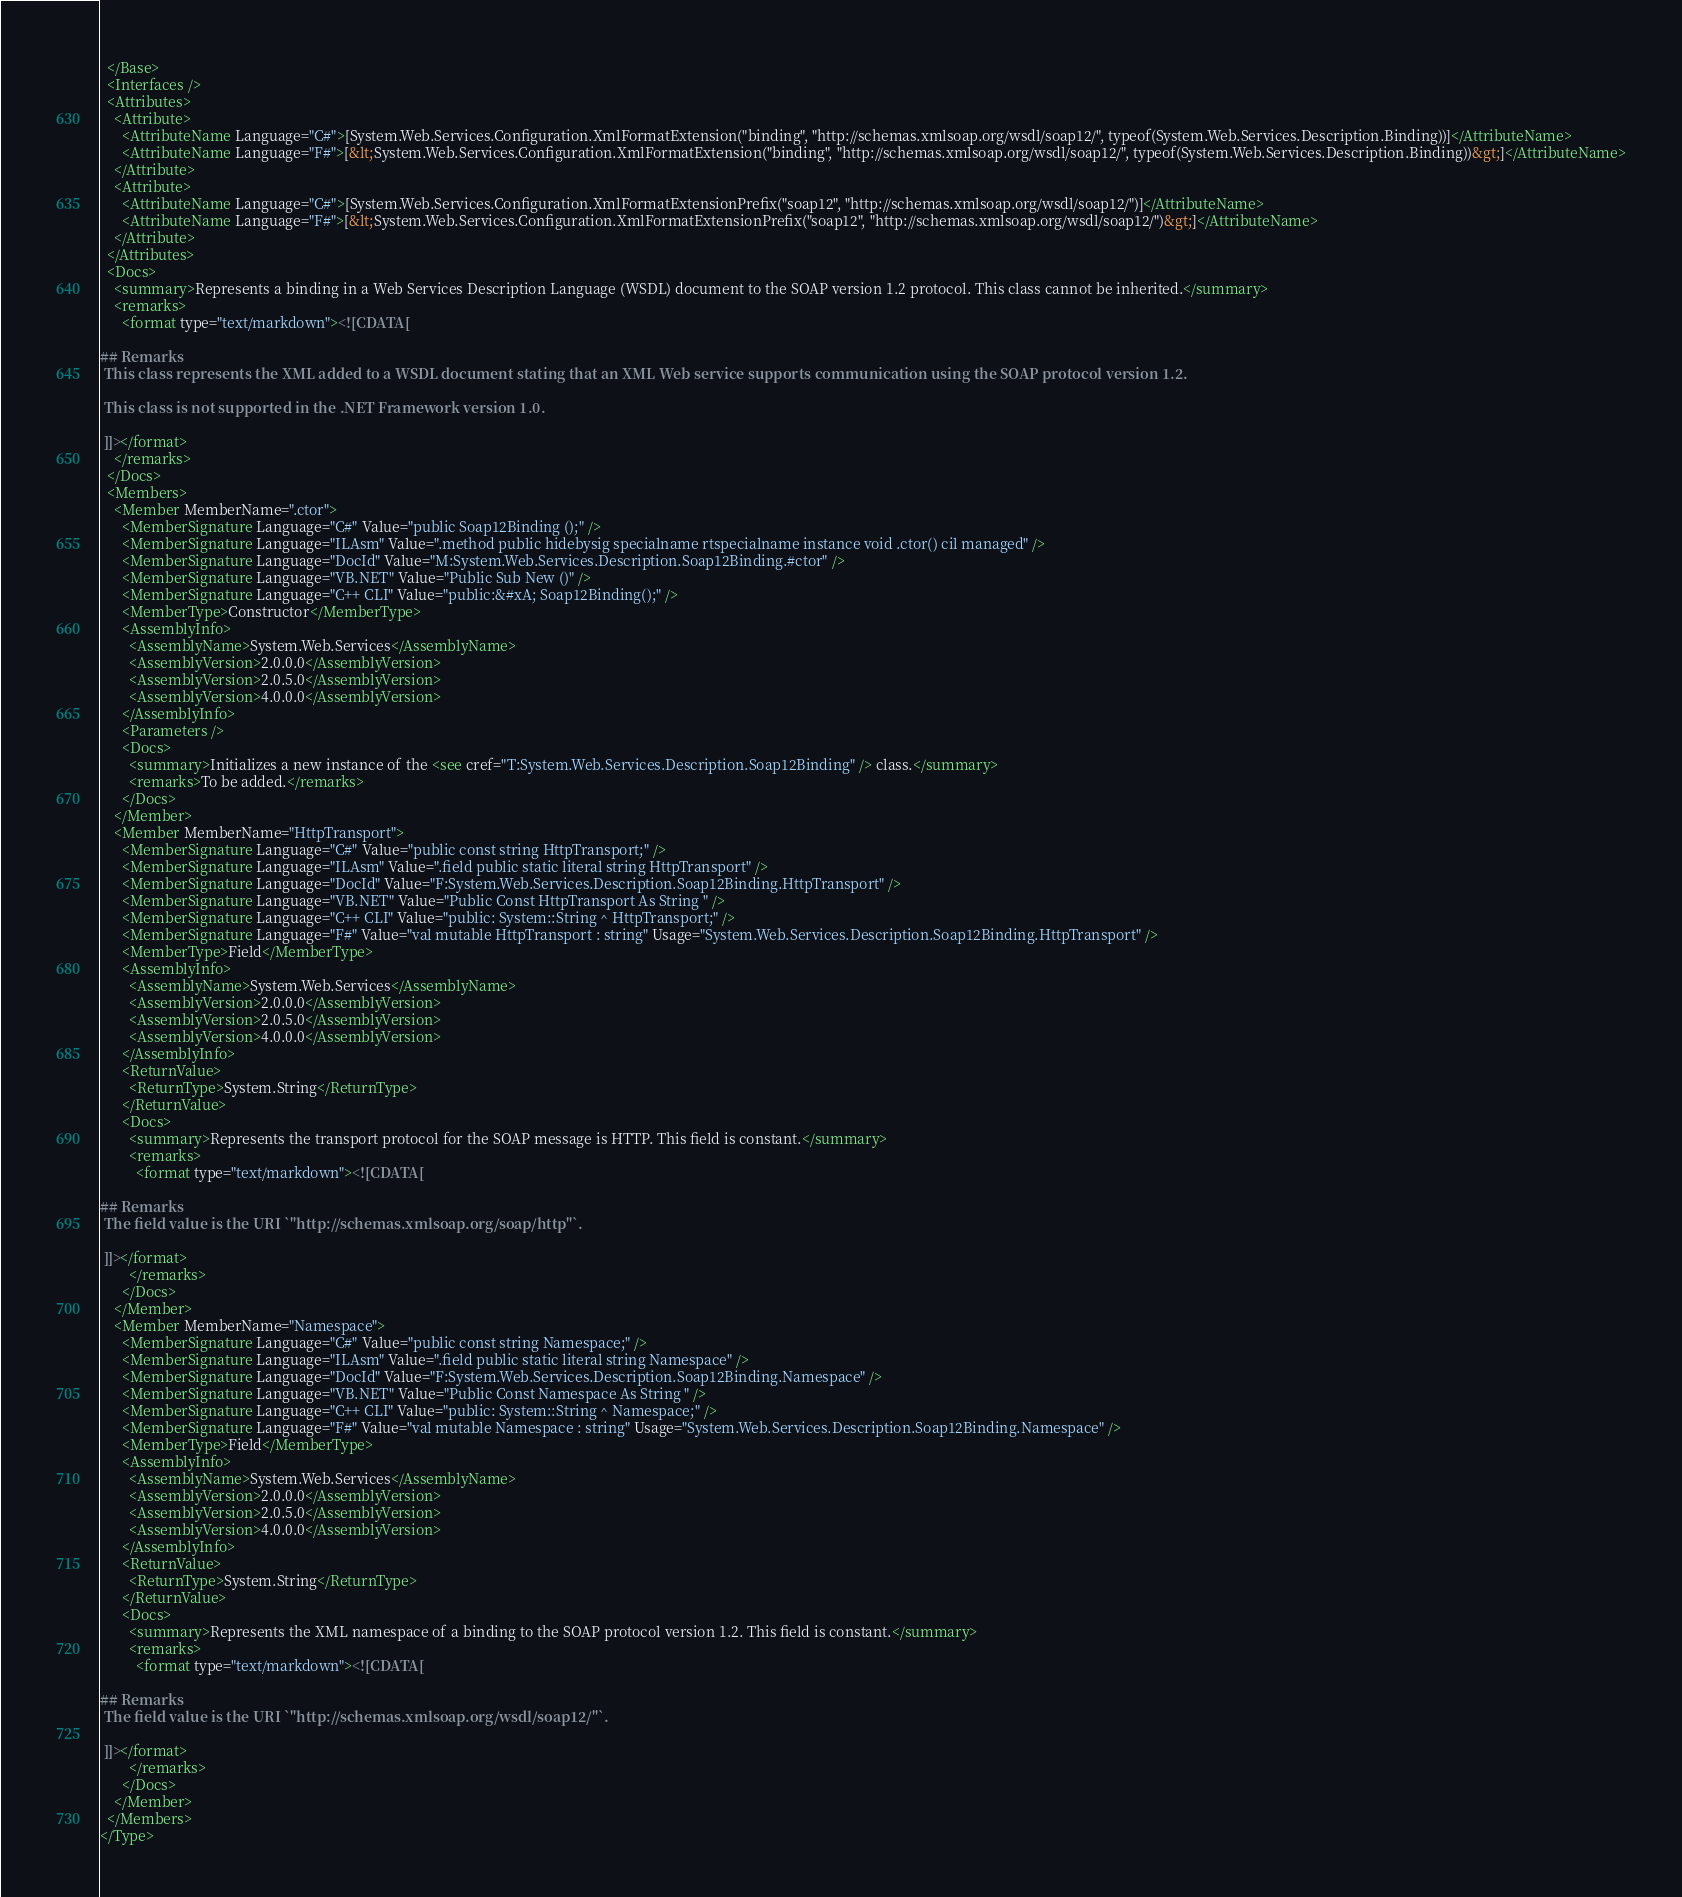Convert code to text. <code><loc_0><loc_0><loc_500><loc_500><_XML_>  </Base>
  <Interfaces />
  <Attributes>
    <Attribute>
      <AttributeName Language="C#">[System.Web.Services.Configuration.XmlFormatExtension("binding", "http://schemas.xmlsoap.org/wsdl/soap12/", typeof(System.Web.Services.Description.Binding))]</AttributeName>
      <AttributeName Language="F#">[&lt;System.Web.Services.Configuration.XmlFormatExtension("binding", "http://schemas.xmlsoap.org/wsdl/soap12/", typeof(System.Web.Services.Description.Binding))&gt;]</AttributeName>
    </Attribute>
    <Attribute>
      <AttributeName Language="C#">[System.Web.Services.Configuration.XmlFormatExtensionPrefix("soap12", "http://schemas.xmlsoap.org/wsdl/soap12/")]</AttributeName>
      <AttributeName Language="F#">[&lt;System.Web.Services.Configuration.XmlFormatExtensionPrefix("soap12", "http://schemas.xmlsoap.org/wsdl/soap12/")&gt;]</AttributeName>
    </Attribute>
  </Attributes>
  <Docs>
    <summary>Represents a binding in a Web Services Description Language (WSDL) document to the SOAP version 1.2 protocol. This class cannot be inherited.</summary>
    <remarks>
      <format type="text/markdown"><![CDATA[  
  
## Remarks  
 This class represents the XML added to a WSDL document stating that an XML Web service supports communication using the SOAP protocol version 1.2.  
  
 This class is not supported in the .NET Framework version 1.0.  
  
 ]]></format>
    </remarks>
  </Docs>
  <Members>
    <Member MemberName=".ctor">
      <MemberSignature Language="C#" Value="public Soap12Binding ();" />
      <MemberSignature Language="ILAsm" Value=".method public hidebysig specialname rtspecialname instance void .ctor() cil managed" />
      <MemberSignature Language="DocId" Value="M:System.Web.Services.Description.Soap12Binding.#ctor" />
      <MemberSignature Language="VB.NET" Value="Public Sub New ()" />
      <MemberSignature Language="C++ CLI" Value="public:&#xA; Soap12Binding();" />
      <MemberType>Constructor</MemberType>
      <AssemblyInfo>
        <AssemblyName>System.Web.Services</AssemblyName>
        <AssemblyVersion>2.0.0.0</AssemblyVersion>
        <AssemblyVersion>2.0.5.0</AssemblyVersion>
        <AssemblyVersion>4.0.0.0</AssemblyVersion>
      </AssemblyInfo>
      <Parameters />
      <Docs>
        <summary>Initializes a new instance of the <see cref="T:System.Web.Services.Description.Soap12Binding" /> class.</summary>
        <remarks>To be added.</remarks>
      </Docs>
    </Member>
    <Member MemberName="HttpTransport">
      <MemberSignature Language="C#" Value="public const string HttpTransport;" />
      <MemberSignature Language="ILAsm" Value=".field public static literal string HttpTransport" />
      <MemberSignature Language="DocId" Value="F:System.Web.Services.Description.Soap12Binding.HttpTransport" />
      <MemberSignature Language="VB.NET" Value="Public Const HttpTransport As String " />
      <MemberSignature Language="C++ CLI" Value="public: System::String ^ HttpTransport;" />
      <MemberSignature Language="F#" Value="val mutable HttpTransport : string" Usage="System.Web.Services.Description.Soap12Binding.HttpTransport" />
      <MemberType>Field</MemberType>
      <AssemblyInfo>
        <AssemblyName>System.Web.Services</AssemblyName>
        <AssemblyVersion>2.0.0.0</AssemblyVersion>
        <AssemblyVersion>2.0.5.0</AssemblyVersion>
        <AssemblyVersion>4.0.0.0</AssemblyVersion>
      </AssemblyInfo>
      <ReturnValue>
        <ReturnType>System.String</ReturnType>
      </ReturnValue>
      <Docs>
        <summary>Represents the transport protocol for the SOAP message is HTTP. This field is constant.</summary>
        <remarks>
          <format type="text/markdown"><![CDATA[  
  
## Remarks  
 The field value is the URI `"http://schemas.xmlsoap.org/soap/http"`.  
  
 ]]></format>
        </remarks>
      </Docs>
    </Member>
    <Member MemberName="Namespace">
      <MemberSignature Language="C#" Value="public const string Namespace;" />
      <MemberSignature Language="ILAsm" Value=".field public static literal string Namespace" />
      <MemberSignature Language="DocId" Value="F:System.Web.Services.Description.Soap12Binding.Namespace" />
      <MemberSignature Language="VB.NET" Value="Public Const Namespace As String " />
      <MemberSignature Language="C++ CLI" Value="public: System::String ^ Namespace;" />
      <MemberSignature Language="F#" Value="val mutable Namespace : string" Usage="System.Web.Services.Description.Soap12Binding.Namespace" />
      <MemberType>Field</MemberType>
      <AssemblyInfo>
        <AssemblyName>System.Web.Services</AssemblyName>
        <AssemblyVersion>2.0.0.0</AssemblyVersion>
        <AssemblyVersion>2.0.5.0</AssemblyVersion>
        <AssemblyVersion>4.0.0.0</AssemblyVersion>
      </AssemblyInfo>
      <ReturnValue>
        <ReturnType>System.String</ReturnType>
      </ReturnValue>
      <Docs>
        <summary>Represents the XML namespace of a binding to the SOAP protocol version 1.2. This field is constant.</summary>
        <remarks>
          <format type="text/markdown"><![CDATA[  
  
## Remarks  
 The field value is the URI `"http://schemas.xmlsoap.org/wsdl/soap12/"`.  
  
 ]]></format>
        </remarks>
      </Docs>
    </Member>
  </Members>
</Type>
</code> 